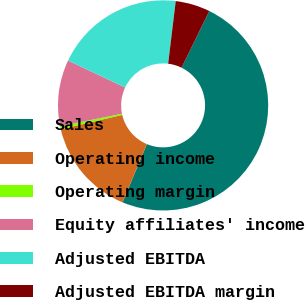Convert chart to OTSL. <chart><loc_0><loc_0><loc_500><loc_500><pie_chart><fcel>Sales<fcel>Operating income<fcel>Operating margin<fcel>Equity affiliates' income<fcel>Adjusted EBITDA<fcel>Adjusted EBITDA margin<nl><fcel>49.07%<fcel>15.05%<fcel>0.47%<fcel>10.19%<fcel>19.91%<fcel>5.33%<nl></chart> 